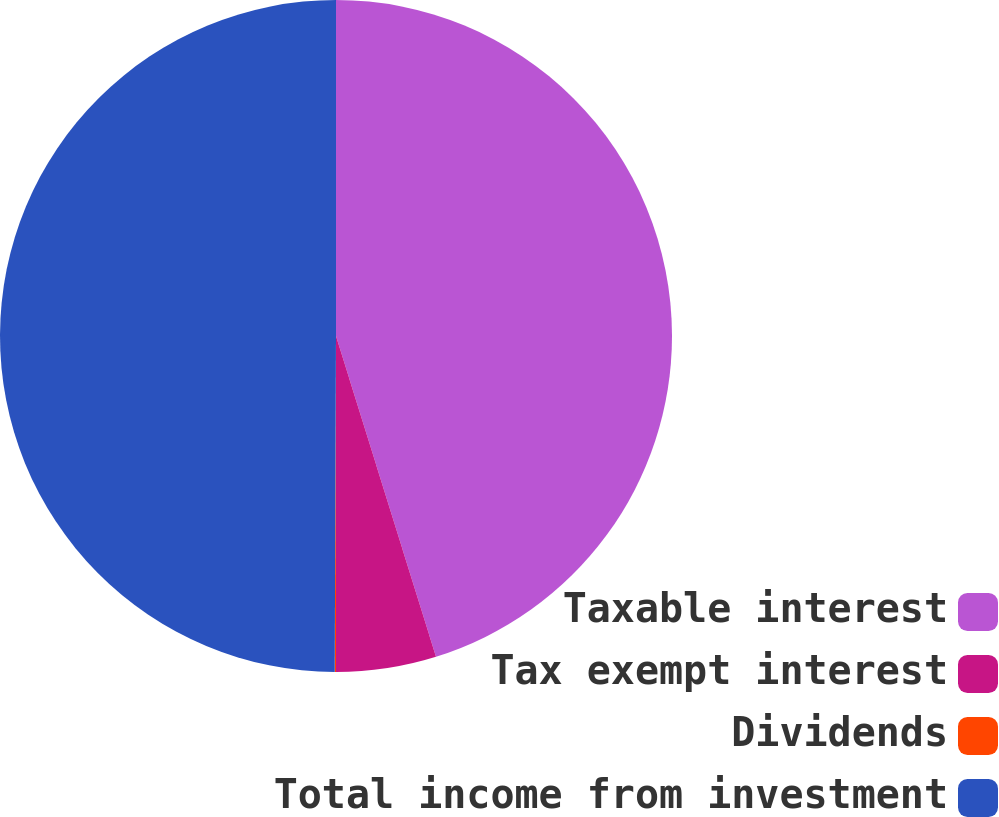<chart> <loc_0><loc_0><loc_500><loc_500><pie_chart><fcel>Taxable interest<fcel>Tax exempt interest<fcel>Dividends<fcel>Total income from investment<nl><fcel>45.19%<fcel>4.81%<fcel>0.06%<fcel>49.94%<nl></chart> 